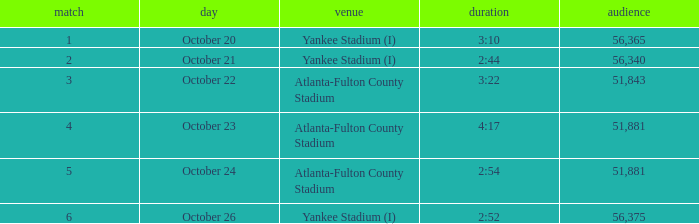What is the highest game number that had a time of 2:44? 2.0. 